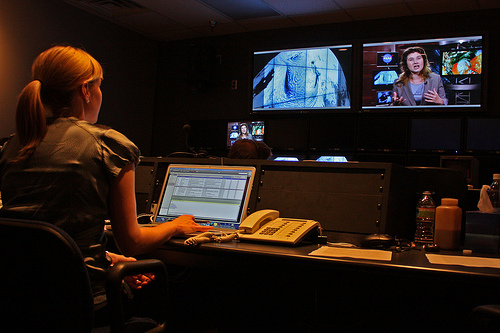What kind of work is being done in this image? The woman in the image seems to be engaged in video editing or production work, as indicated by the professional equipment and multiple monitors displaying different content. 